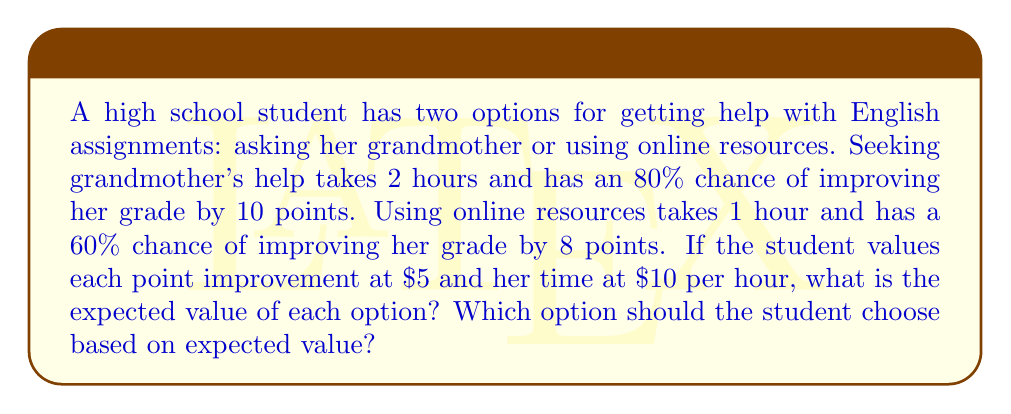Help me with this question. Let's calculate the expected value for each option:

1. Grandmother's help:
   - Time cost: 2 hours × $10/hour = $20
   - Probability of success: 80% = 0.8
   - Value of improvement: 10 points × $5/point = $50
   - Expected value of improvement: $50 × 0.8 = $40
   
   Expected value = Value of improvement - Time cost
   $$EV_{grandmother} = 40 - 20 = $20$$

2. Online resources:
   - Time cost: 1 hour × $10/hour = $10
   - Probability of success: 60% = 0.6
   - Value of improvement: 8 points × $5/point = $40
   - Expected value of improvement: $40 × 0.6 = $24
   
   Expected value = Value of improvement - Time cost
   $$EV_{online} = 24 - 10 = $14$$

To determine which option the student should choose, we compare the expected values:

$$EV_{grandmother} > EV_{online}$$
$$20 > 14$$

Therefore, based on expected value, the student should choose to seek her grandmother's help.
Answer: The expected value of seeking grandmother's help is $20, and the expected value of using online resources is $14. The student should choose to seek her grandmother's help as it has a higher expected value. 